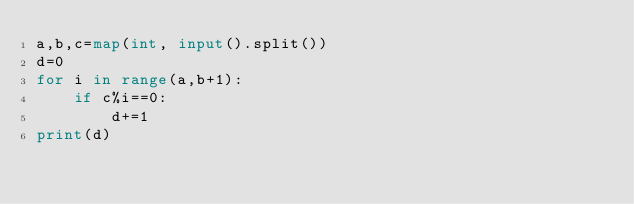Convert code to text. <code><loc_0><loc_0><loc_500><loc_500><_Python_>a,b,c=map(int, input().split())
d=0
for i in range(a,b+1):
    if c%i==0:
        d+=1
print(d)</code> 